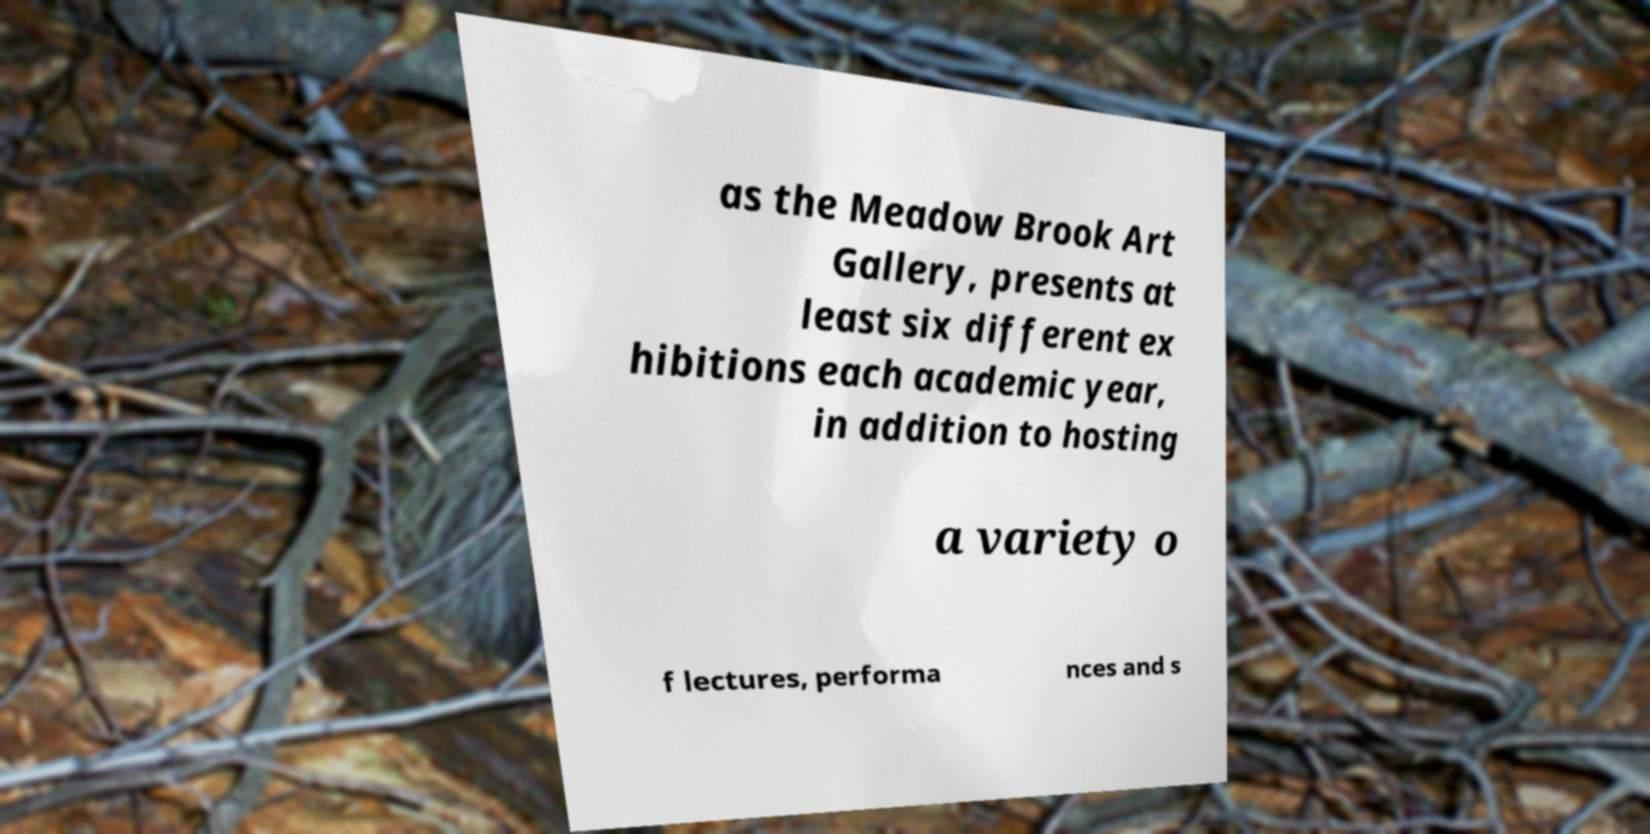Can you read and provide the text displayed in the image?This photo seems to have some interesting text. Can you extract and type it out for me? as the Meadow Brook Art Gallery, presents at least six different ex hibitions each academic year, in addition to hosting a variety o f lectures, performa nces and s 